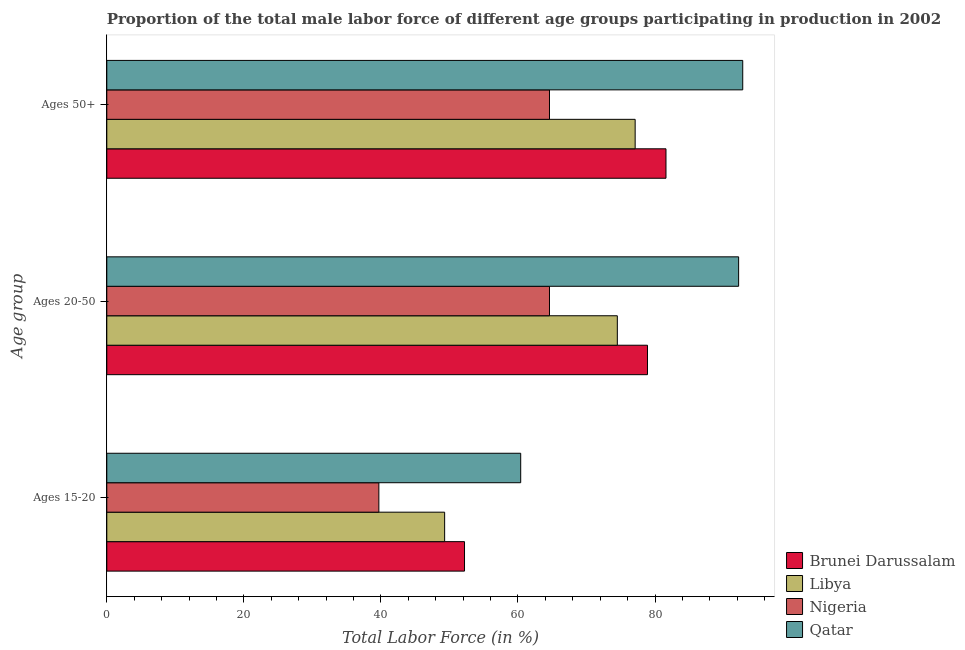Are the number of bars on each tick of the Y-axis equal?
Make the answer very short. Yes. How many bars are there on the 1st tick from the top?
Your answer should be very brief. 4. What is the label of the 3rd group of bars from the top?
Your answer should be very brief. Ages 15-20. What is the percentage of male labor force within the age group 20-50 in Brunei Darussalam?
Provide a succinct answer. 78.9. Across all countries, what is the maximum percentage of male labor force within the age group 15-20?
Your response must be concise. 60.4. Across all countries, what is the minimum percentage of male labor force within the age group 20-50?
Give a very brief answer. 64.6. In which country was the percentage of male labor force within the age group 20-50 maximum?
Keep it short and to the point. Qatar. In which country was the percentage of male labor force within the age group 20-50 minimum?
Keep it short and to the point. Nigeria. What is the total percentage of male labor force within the age group 20-50 in the graph?
Offer a very short reply. 310.2. What is the difference between the percentage of male labor force within the age group 20-50 in Qatar and that in Nigeria?
Give a very brief answer. 27.6. What is the difference between the percentage of male labor force within the age group 20-50 in Qatar and the percentage of male labor force above age 50 in Nigeria?
Make the answer very short. 27.6. What is the average percentage of male labor force above age 50 per country?
Keep it short and to the point. 79.02. What is the difference between the percentage of male labor force above age 50 and percentage of male labor force within the age group 20-50 in Qatar?
Provide a succinct answer. 0.6. In how many countries, is the percentage of male labor force above age 50 greater than 4 %?
Offer a terse response. 4. What is the ratio of the percentage of male labor force within the age group 15-20 in Qatar to that in Nigeria?
Your answer should be very brief. 1.52. Is the percentage of male labor force above age 50 in Qatar less than that in Brunei Darussalam?
Provide a succinct answer. No. What is the difference between the highest and the second highest percentage of male labor force within the age group 15-20?
Make the answer very short. 8.2. What is the difference between the highest and the lowest percentage of male labor force within the age group 20-50?
Your response must be concise. 27.6. In how many countries, is the percentage of male labor force above age 50 greater than the average percentage of male labor force above age 50 taken over all countries?
Make the answer very short. 2. Is the sum of the percentage of male labor force within the age group 20-50 in Brunei Darussalam and Nigeria greater than the maximum percentage of male labor force within the age group 15-20 across all countries?
Give a very brief answer. Yes. What does the 4th bar from the top in Ages 20-50 represents?
Ensure brevity in your answer.  Brunei Darussalam. What does the 1st bar from the bottom in Ages 15-20 represents?
Offer a very short reply. Brunei Darussalam. Is it the case that in every country, the sum of the percentage of male labor force within the age group 15-20 and percentage of male labor force within the age group 20-50 is greater than the percentage of male labor force above age 50?
Keep it short and to the point. Yes. How many bars are there?
Provide a short and direct response. 12. Are all the bars in the graph horizontal?
Offer a very short reply. Yes. How many countries are there in the graph?
Give a very brief answer. 4. Where does the legend appear in the graph?
Keep it short and to the point. Bottom right. How are the legend labels stacked?
Keep it short and to the point. Vertical. What is the title of the graph?
Provide a succinct answer. Proportion of the total male labor force of different age groups participating in production in 2002. What is the label or title of the X-axis?
Provide a succinct answer. Total Labor Force (in %). What is the label or title of the Y-axis?
Offer a terse response. Age group. What is the Total Labor Force (in %) in Brunei Darussalam in Ages 15-20?
Your response must be concise. 52.2. What is the Total Labor Force (in %) in Libya in Ages 15-20?
Keep it short and to the point. 49.3. What is the Total Labor Force (in %) in Nigeria in Ages 15-20?
Ensure brevity in your answer.  39.7. What is the Total Labor Force (in %) in Qatar in Ages 15-20?
Keep it short and to the point. 60.4. What is the Total Labor Force (in %) of Brunei Darussalam in Ages 20-50?
Give a very brief answer. 78.9. What is the Total Labor Force (in %) of Libya in Ages 20-50?
Your answer should be compact. 74.5. What is the Total Labor Force (in %) of Nigeria in Ages 20-50?
Ensure brevity in your answer.  64.6. What is the Total Labor Force (in %) in Qatar in Ages 20-50?
Offer a terse response. 92.2. What is the Total Labor Force (in %) of Brunei Darussalam in Ages 50+?
Your answer should be compact. 81.6. What is the Total Labor Force (in %) of Libya in Ages 50+?
Make the answer very short. 77.1. What is the Total Labor Force (in %) in Nigeria in Ages 50+?
Your answer should be compact. 64.6. What is the Total Labor Force (in %) of Qatar in Ages 50+?
Give a very brief answer. 92.8. Across all Age group, what is the maximum Total Labor Force (in %) of Brunei Darussalam?
Provide a succinct answer. 81.6. Across all Age group, what is the maximum Total Labor Force (in %) in Libya?
Give a very brief answer. 77.1. Across all Age group, what is the maximum Total Labor Force (in %) of Nigeria?
Offer a very short reply. 64.6. Across all Age group, what is the maximum Total Labor Force (in %) of Qatar?
Give a very brief answer. 92.8. Across all Age group, what is the minimum Total Labor Force (in %) of Brunei Darussalam?
Provide a short and direct response. 52.2. Across all Age group, what is the minimum Total Labor Force (in %) of Libya?
Give a very brief answer. 49.3. Across all Age group, what is the minimum Total Labor Force (in %) of Nigeria?
Provide a succinct answer. 39.7. Across all Age group, what is the minimum Total Labor Force (in %) in Qatar?
Your answer should be compact. 60.4. What is the total Total Labor Force (in %) in Brunei Darussalam in the graph?
Provide a short and direct response. 212.7. What is the total Total Labor Force (in %) in Libya in the graph?
Provide a short and direct response. 200.9. What is the total Total Labor Force (in %) of Nigeria in the graph?
Make the answer very short. 168.9. What is the total Total Labor Force (in %) of Qatar in the graph?
Give a very brief answer. 245.4. What is the difference between the Total Labor Force (in %) in Brunei Darussalam in Ages 15-20 and that in Ages 20-50?
Provide a short and direct response. -26.7. What is the difference between the Total Labor Force (in %) of Libya in Ages 15-20 and that in Ages 20-50?
Keep it short and to the point. -25.2. What is the difference between the Total Labor Force (in %) in Nigeria in Ages 15-20 and that in Ages 20-50?
Offer a terse response. -24.9. What is the difference between the Total Labor Force (in %) in Qatar in Ages 15-20 and that in Ages 20-50?
Provide a short and direct response. -31.8. What is the difference between the Total Labor Force (in %) in Brunei Darussalam in Ages 15-20 and that in Ages 50+?
Ensure brevity in your answer.  -29.4. What is the difference between the Total Labor Force (in %) of Libya in Ages 15-20 and that in Ages 50+?
Your answer should be very brief. -27.8. What is the difference between the Total Labor Force (in %) in Nigeria in Ages 15-20 and that in Ages 50+?
Your answer should be very brief. -24.9. What is the difference between the Total Labor Force (in %) in Qatar in Ages 15-20 and that in Ages 50+?
Offer a very short reply. -32.4. What is the difference between the Total Labor Force (in %) in Libya in Ages 20-50 and that in Ages 50+?
Make the answer very short. -2.6. What is the difference between the Total Labor Force (in %) of Qatar in Ages 20-50 and that in Ages 50+?
Provide a short and direct response. -0.6. What is the difference between the Total Labor Force (in %) of Brunei Darussalam in Ages 15-20 and the Total Labor Force (in %) of Libya in Ages 20-50?
Keep it short and to the point. -22.3. What is the difference between the Total Labor Force (in %) in Brunei Darussalam in Ages 15-20 and the Total Labor Force (in %) in Nigeria in Ages 20-50?
Your answer should be very brief. -12.4. What is the difference between the Total Labor Force (in %) in Libya in Ages 15-20 and the Total Labor Force (in %) in Nigeria in Ages 20-50?
Ensure brevity in your answer.  -15.3. What is the difference between the Total Labor Force (in %) of Libya in Ages 15-20 and the Total Labor Force (in %) of Qatar in Ages 20-50?
Ensure brevity in your answer.  -42.9. What is the difference between the Total Labor Force (in %) in Nigeria in Ages 15-20 and the Total Labor Force (in %) in Qatar in Ages 20-50?
Provide a short and direct response. -52.5. What is the difference between the Total Labor Force (in %) of Brunei Darussalam in Ages 15-20 and the Total Labor Force (in %) of Libya in Ages 50+?
Your answer should be very brief. -24.9. What is the difference between the Total Labor Force (in %) of Brunei Darussalam in Ages 15-20 and the Total Labor Force (in %) of Qatar in Ages 50+?
Offer a terse response. -40.6. What is the difference between the Total Labor Force (in %) of Libya in Ages 15-20 and the Total Labor Force (in %) of Nigeria in Ages 50+?
Your answer should be compact. -15.3. What is the difference between the Total Labor Force (in %) of Libya in Ages 15-20 and the Total Labor Force (in %) of Qatar in Ages 50+?
Your response must be concise. -43.5. What is the difference between the Total Labor Force (in %) in Nigeria in Ages 15-20 and the Total Labor Force (in %) in Qatar in Ages 50+?
Your answer should be very brief. -53.1. What is the difference between the Total Labor Force (in %) in Libya in Ages 20-50 and the Total Labor Force (in %) in Nigeria in Ages 50+?
Make the answer very short. 9.9. What is the difference between the Total Labor Force (in %) of Libya in Ages 20-50 and the Total Labor Force (in %) of Qatar in Ages 50+?
Ensure brevity in your answer.  -18.3. What is the difference between the Total Labor Force (in %) of Nigeria in Ages 20-50 and the Total Labor Force (in %) of Qatar in Ages 50+?
Your response must be concise. -28.2. What is the average Total Labor Force (in %) in Brunei Darussalam per Age group?
Provide a short and direct response. 70.9. What is the average Total Labor Force (in %) in Libya per Age group?
Give a very brief answer. 66.97. What is the average Total Labor Force (in %) in Nigeria per Age group?
Your response must be concise. 56.3. What is the average Total Labor Force (in %) of Qatar per Age group?
Your answer should be compact. 81.8. What is the difference between the Total Labor Force (in %) of Brunei Darussalam and Total Labor Force (in %) of Libya in Ages 15-20?
Offer a terse response. 2.9. What is the difference between the Total Labor Force (in %) in Libya and Total Labor Force (in %) in Nigeria in Ages 15-20?
Keep it short and to the point. 9.6. What is the difference between the Total Labor Force (in %) in Nigeria and Total Labor Force (in %) in Qatar in Ages 15-20?
Make the answer very short. -20.7. What is the difference between the Total Labor Force (in %) of Brunei Darussalam and Total Labor Force (in %) of Libya in Ages 20-50?
Make the answer very short. 4.4. What is the difference between the Total Labor Force (in %) of Brunei Darussalam and Total Labor Force (in %) of Nigeria in Ages 20-50?
Offer a very short reply. 14.3. What is the difference between the Total Labor Force (in %) of Libya and Total Labor Force (in %) of Nigeria in Ages 20-50?
Offer a very short reply. 9.9. What is the difference between the Total Labor Force (in %) in Libya and Total Labor Force (in %) in Qatar in Ages 20-50?
Offer a very short reply. -17.7. What is the difference between the Total Labor Force (in %) in Nigeria and Total Labor Force (in %) in Qatar in Ages 20-50?
Ensure brevity in your answer.  -27.6. What is the difference between the Total Labor Force (in %) in Brunei Darussalam and Total Labor Force (in %) in Nigeria in Ages 50+?
Offer a terse response. 17. What is the difference between the Total Labor Force (in %) of Brunei Darussalam and Total Labor Force (in %) of Qatar in Ages 50+?
Make the answer very short. -11.2. What is the difference between the Total Labor Force (in %) in Libya and Total Labor Force (in %) in Nigeria in Ages 50+?
Offer a terse response. 12.5. What is the difference between the Total Labor Force (in %) in Libya and Total Labor Force (in %) in Qatar in Ages 50+?
Provide a short and direct response. -15.7. What is the difference between the Total Labor Force (in %) in Nigeria and Total Labor Force (in %) in Qatar in Ages 50+?
Your response must be concise. -28.2. What is the ratio of the Total Labor Force (in %) in Brunei Darussalam in Ages 15-20 to that in Ages 20-50?
Offer a very short reply. 0.66. What is the ratio of the Total Labor Force (in %) of Libya in Ages 15-20 to that in Ages 20-50?
Keep it short and to the point. 0.66. What is the ratio of the Total Labor Force (in %) in Nigeria in Ages 15-20 to that in Ages 20-50?
Your answer should be very brief. 0.61. What is the ratio of the Total Labor Force (in %) in Qatar in Ages 15-20 to that in Ages 20-50?
Give a very brief answer. 0.66. What is the ratio of the Total Labor Force (in %) in Brunei Darussalam in Ages 15-20 to that in Ages 50+?
Make the answer very short. 0.64. What is the ratio of the Total Labor Force (in %) in Libya in Ages 15-20 to that in Ages 50+?
Your response must be concise. 0.64. What is the ratio of the Total Labor Force (in %) of Nigeria in Ages 15-20 to that in Ages 50+?
Provide a short and direct response. 0.61. What is the ratio of the Total Labor Force (in %) of Qatar in Ages 15-20 to that in Ages 50+?
Make the answer very short. 0.65. What is the ratio of the Total Labor Force (in %) of Brunei Darussalam in Ages 20-50 to that in Ages 50+?
Your response must be concise. 0.97. What is the ratio of the Total Labor Force (in %) in Libya in Ages 20-50 to that in Ages 50+?
Provide a succinct answer. 0.97. What is the ratio of the Total Labor Force (in %) in Nigeria in Ages 20-50 to that in Ages 50+?
Provide a succinct answer. 1. What is the ratio of the Total Labor Force (in %) of Qatar in Ages 20-50 to that in Ages 50+?
Provide a short and direct response. 0.99. What is the difference between the highest and the second highest Total Labor Force (in %) of Brunei Darussalam?
Make the answer very short. 2.7. What is the difference between the highest and the lowest Total Labor Force (in %) in Brunei Darussalam?
Your answer should be very brief. 29.4. What is the difference between the highest and the lowest Total Labor Force (in %) in Libya?
Ensure brevity in your answer.  27.8. What is the difference between the highest and the lowest Total Labor Force (in %) in Nigeria?
Offer a terse response. 24.9. What is the difference between the highest and the lowest Total Labor Force (in %) in Qatar?
Your answer should be compact. 32.4. 